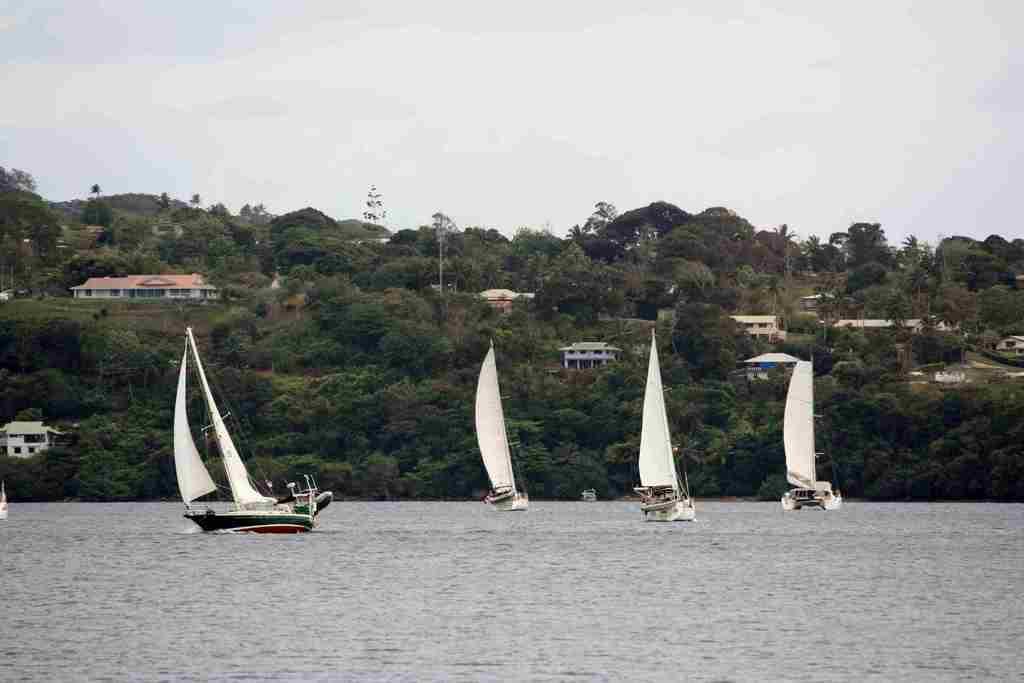How would you summarize this image in a sentence or two? At the bottom of the image there is water. On the water there are boats with clothes, rods and ropes. Behind them there are many trees and there are few buildings. At the top of the image there is sky. 